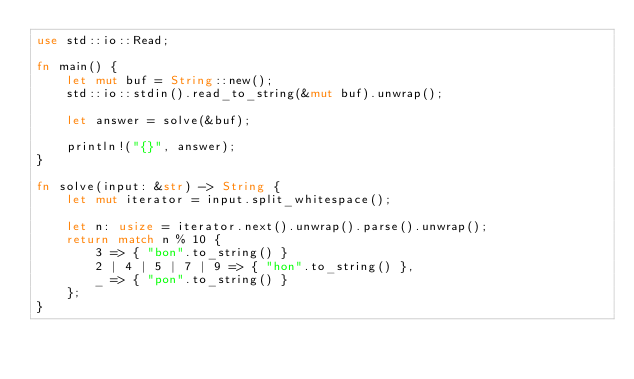Convert code to text. <code><loc_0><loc_0><loc_500><loc_500><_Rust_>use std::io::Read;

fn main() {
    let mut buf = String::new();
    std::io::stdin().read_to_string(&mut buf).unwrap();

    let answer = solve(&buf);

    println!("{}", answer);
}

fn solve(input: &str) -> String {
    let mut iterator = input.split_whitespace();

    let n: usize = iterator.next().unwrap().parse().unwrap();
    return match n % 10 {
        3 => { "bon".to_string() }
        2 | 4 | 5 | 7 | 9 => { "hon".to_string() },
        _ => { "pon".to_string() }
    };
}
</code> 